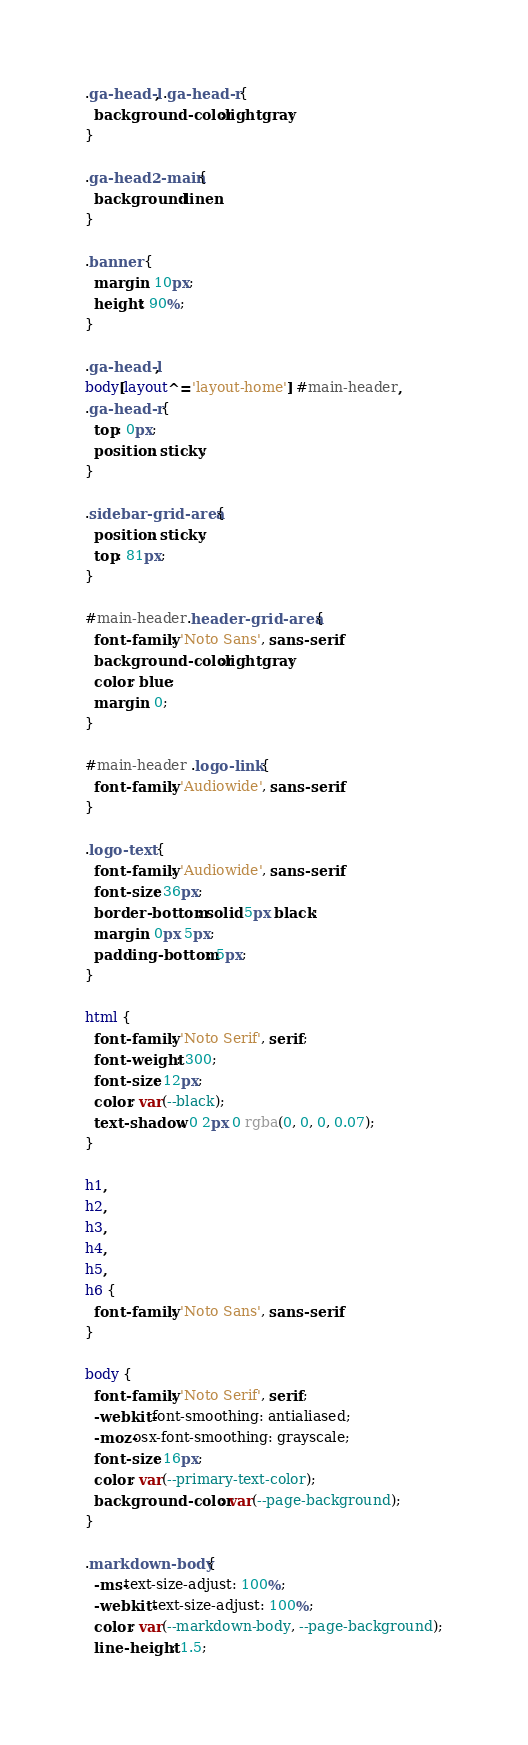Convert code to text. <code><loc_0><loc_0><loc_500><loc_500><_CSS_>.ga-head-l, .ga-head-r {
  background-color:lightgray;
}

.ga-head2-main {
  background:linen;
}

.banner {
  margin: 10px;
  height: 90%;
}

.ga-head-l,
body[layout^='layout-home'] #main-header,
.ga-head-r {
  top: 0px;
  position: sticky;
}

.sidebar-grid-area {
  position: sticky;
  top: 81px;
}

#main-header.header-grid-area {
  font-family: 'Noto Sans', sans-serif;
  background-color:lightgray;
  color: blue;
  margin: 0;
}

#main-header .logo-link {
  font-family: 'Audiowide', sans-serif;
}

.logo-text {
  font-family: 'Audiowide', sans-serif;
  font-size: 36px;
  border-bottom: solid 5px black;
  margin: 0px 5px;
  padding-bottom: 5px;
}

html {
  font-family: 'Noto Serif', serif;
  font-weight: 300;
  font-size: 12px;
  color: var(--black);
  text-shadow: 0 2px 0 rgba(0, 0, 0, 0.07);
}

h1,
h2,
h3,
h4,
h5,
h6 {
  font-family: 'Noto Sans', sans-serif;
}

body {
  font-family: 'Noto Serif', serif;
  -webkit-font-smoothing: antialiased;
  -moz-osx-font-smoothing: grayscale;
  font-size: 16px;
  color: var(--primary-text-color);
  background-color: var(--page-background);
}

.markdown-body {
  -ms-text-size-adjust: 100%;
  -webkit-text-size-adjust: 100%;
  color: var(--markdown-body, --page-background);
  line-height: 1.5;</code> 